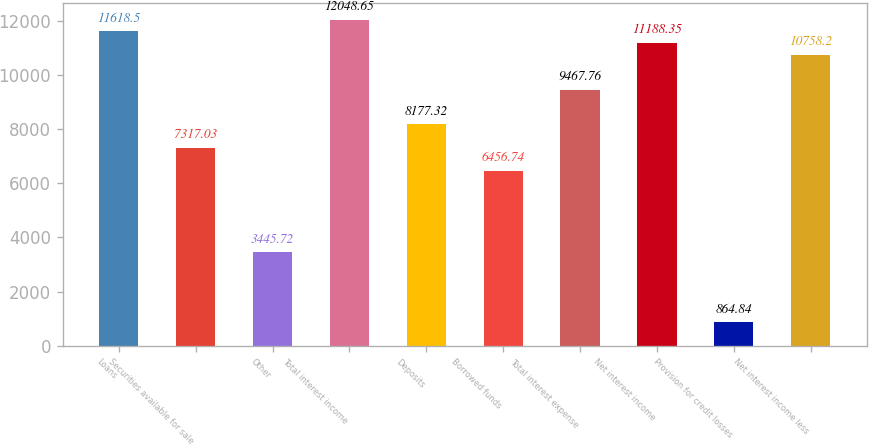Convert chart to OTSL. <chart><loc_0><loc_0><loc_500><loc_500><bar_chart><fcel>Loans<fcel>Securities available for sale<fcel>Other<fcel>Total interest income<fcel>Deposits<fcel>Borrowed funds<fcel>Total interest expense<fcel>Net interest income<fcel>Provision for credit losses<fcel>Net interest income less<nl><fcel>11618.5<fcel>7317.03<fcel>3445.72<fcel>12048.6<fcel>8177.32<fcel>6456.74<fcel>9467.76<fcel>11188.4<fcel>864.84<fcel>10758.2<nl></chart> 